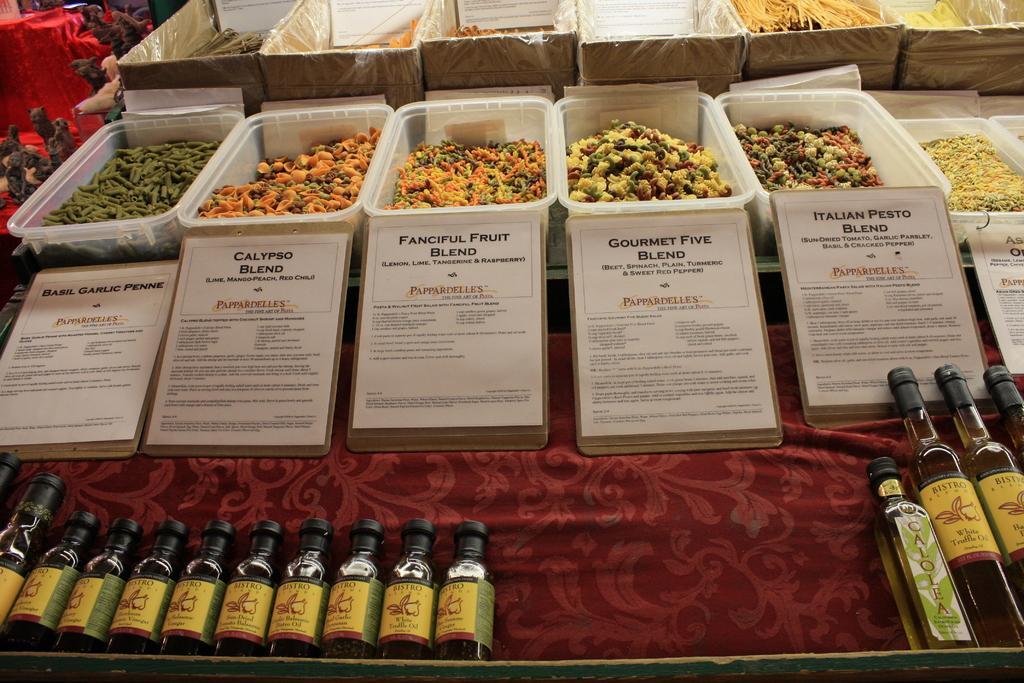Can you describe this image briefly? In this picture I can see plastic baskets. I can see food items in it. I can see the bottles. I can see the boards. 